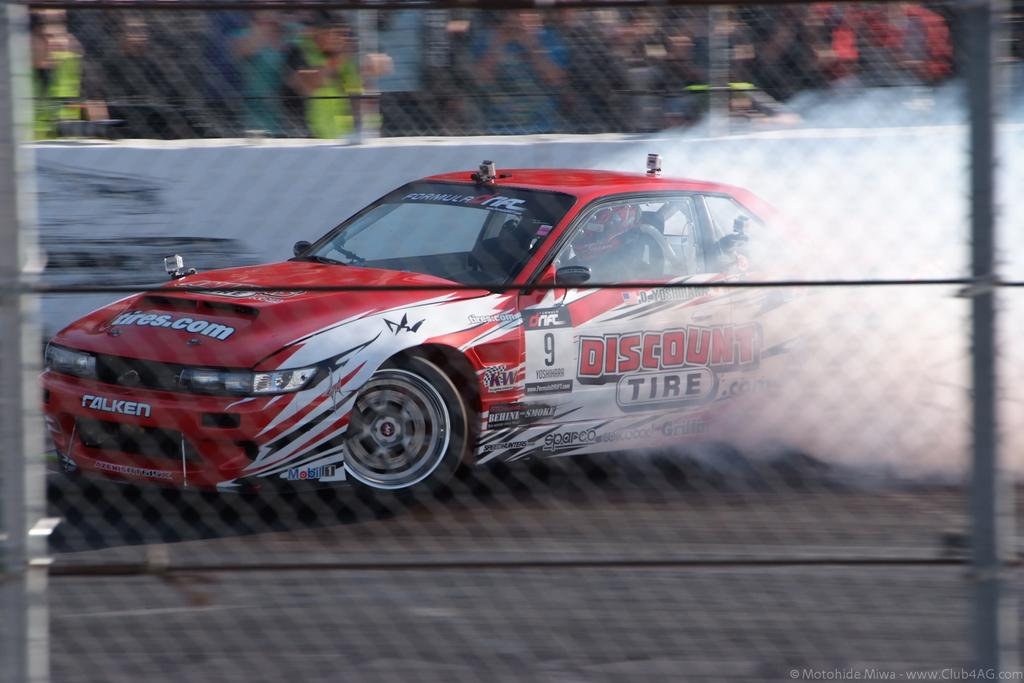What is the car doing in the image? The car is drifting on the road in the image. What is coming out of the car? The car is releasing smoke in the image. What can be seen in the background of the image? There is a fence in the image. Where are the audience members located in the image? The audience members are standing behind a wall in the image. How many steps can be seen in the image? There are no steps visible in the image. What is the distance between the car and the audience members in the image? The provided facts do not give information about the distance between the car and the audience members, so it cannot be determined from the image. 